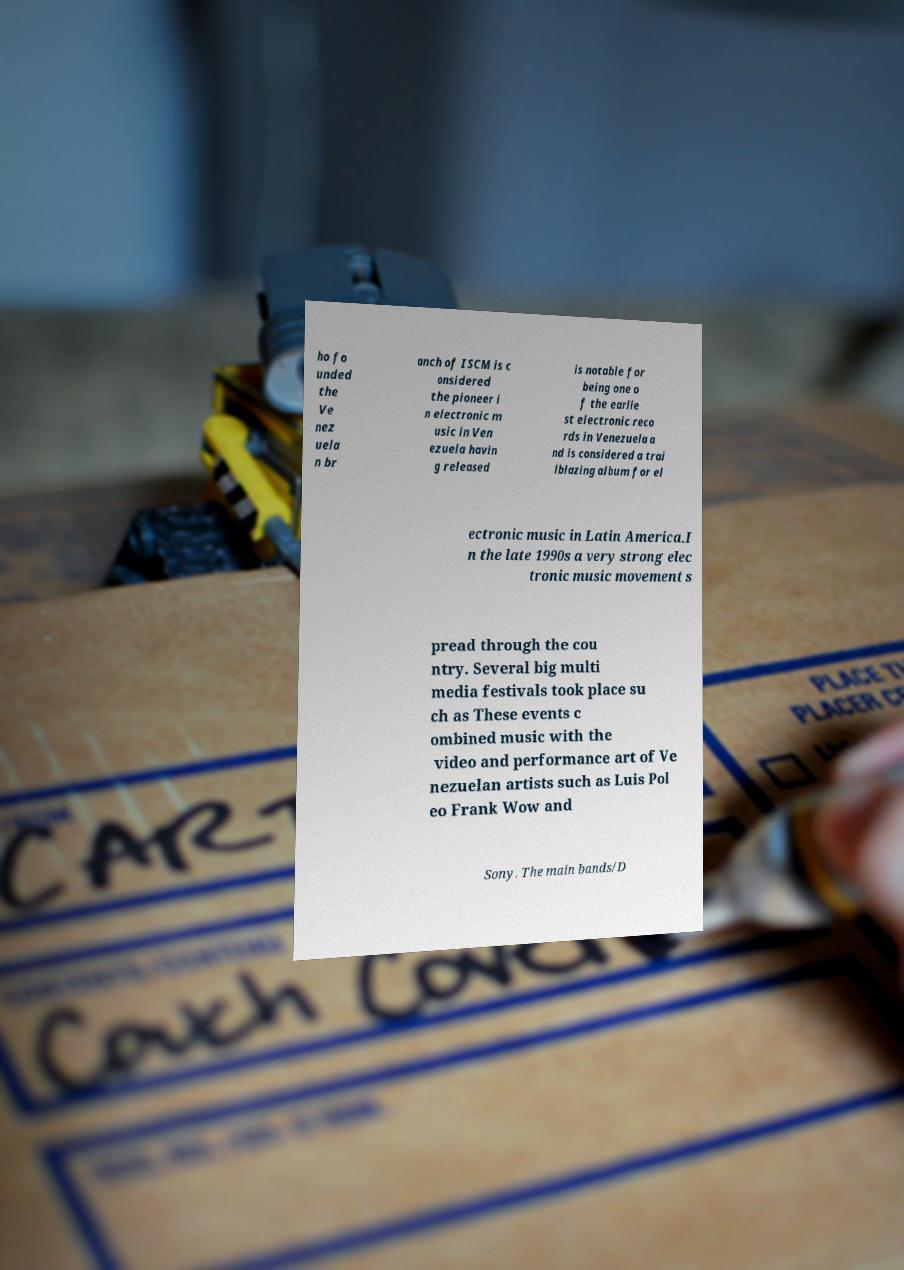Please identify and transcribe the text found in this image. ho fo unded the Ve nez uela n br anch of ISCM is c onsidered the pioneer i n electronic m usic in Ven ezuela havin g released is notable for being one o f the earlie st electronic reco rds in Venezuela a nd is considered a trai lblazing album for el ectronic music in Latin America.I n the late 1990s a very strong elec tronic music movement s pread through the cou ntry. Several big multi media festivals took place su ch as These events c ombined music with the video and performance art of Ve nezuelan artists such as Luis Pol eo Frank Wow and Sony. The main bands/D 